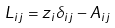Convert formula to latex. <formula><loc_0><loc_0><loc_500><loc_500>L _ { i j } = z _ { i } \delta _ { i j } - A _ { i j }</formula> 